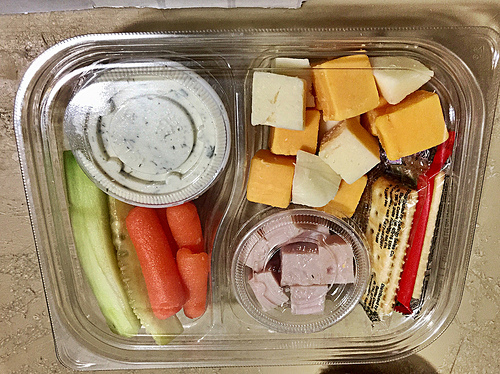<image>
Can you confirm if the ham is on the cracker? No. The ham is not positioned on the cracker. They may be near each other, but the ham is not supported by or resting on top of the cracker. Where is the cheese in relation to the meat? Is it behind the meat? No. The cheese is not behind the meat. From this viewpoint, the cheese appears to be positioned elsewhere in the scene. 